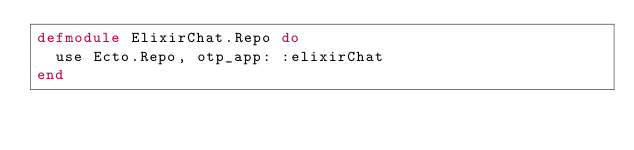<code> <loc_0><loc_0><loc_500><loc_500><_Elixir_>defmodule ElixirChat.Repo do
  use Ecto.Repo, otp_app: :elixirChat
end
</code> 